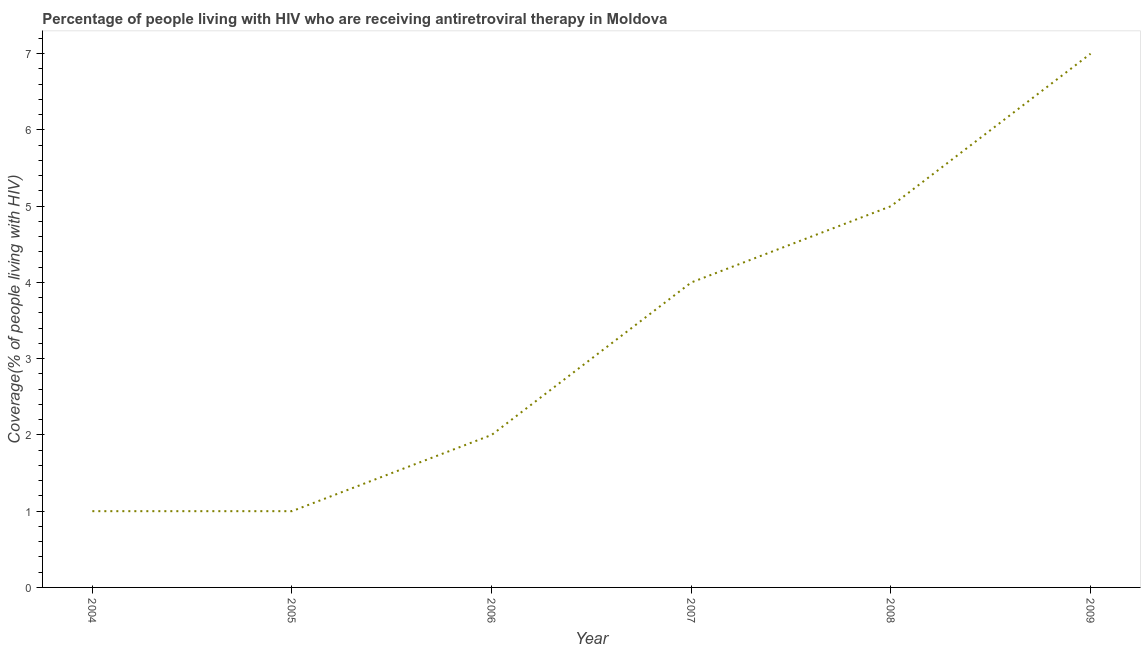What is the antiretroviral therapy coverage in 2004?
Provide a succinct answer. 1. Across all years, what is the maximum antiretroviral therapy coverage?
Offer a very short reply. 7. Across all years, what is the minimum antiretroviral therapy coverage?
Your answer should be compact. 1. In which year was the antiretroviral therapy coverage maximum?
Provide a short and direct response. 2009. In which year was the antiretroviral therapy coverage minimum?
Offer a very short reply. 2004. What is the sum of the antiretroviral therapy coverage?
Provide a short and direct response. 20. What is the difference between the antiretroviral therapy coverage in 2006 and 2007?
Provide a short and direct response. -2. What is the average antiretroviral therapy coverage per year?
Give a very brief answer. 3.33. What is the ratio of the antiretroviral therapy coverage in 2005 to that in 2009?
Provide a short and direct response. 0.14. Is the antiretroviral therapy coverage in 2007 less than that in 2008?
Give a very brief answer. Yes. What is the difference between the highest and the second highest antiretroviral therapy coverage?
Make the answer very short. 2. What is the difference between the highest and the lowest antiretroviral therapy coverage?
Give a very brief answer. 6. Does the antiretroviral therapy coverage monotonically increase over the years?
Ensure brevity in your answer.  No. How many years are there in the graph?
Offer a terse response. 6. What is the difference between two consecutive major ticks on the Y-axis?
Give a very brief answer. 1. Are the values on the major ticks of Y-axis written in scientific E-notation?
Keep it short and to the point. No. Does the graph contain grids?
Give a very brief answer. No. What is the title of the graph?
Provide a short and direct response. Percentage of people living with HIV who are receiving antiretroviral therapy in Moldova. What is the label or title of the Y-axis?
Your response must be concise. Coverage(% of people living with HIV). What is the Coverage(% of people living with HIV) of 2007?
Keep it short and to the point. 4. What is the Coverage(% of people living with HIV) in 2009?
Give a very brief answer. 7. What is the difference between the Coverage(% of people living with HIV) in 2004 and 2005?
Offer a very short reply. 0. What is the difference between the Coverage(% of people living with HIV) in 2004 and 2007?
Make the answer very short. -3. What is the difference between the Coverage(% of people living with HIV) in 2005 and 2008?
Provide a succinct answer. -4. What is the difference between the Coverage(% of people living with HIV) in 2005 and 2009?
Offer a terse response. -6. What is the difference between the Coverage(% of people living with HIV) in 2007 and 2008?
Provide a short and direct response. -1. What is the difference between the Coverage(% of people living with HIV) in 2008 and 2009?
Offer a terse response. -2. What is the ratio of the Coverage(% of people living with HIV) in 2004 to that in 2008?
Ensure brevity in your answer.  0.2. What is the ratio of the Coverage(% of people living with HIV) in 2004 to that in 2009?
Your answer should be compact. 0.14. What is the ratio of the Coverage(% of people living with HIV) in 2005 to that in 2006?
Give a very brief answer. 0.5. What is the ratio of the Coverage(% of people living with HIV) in 2005 to that in 2007?
Your response must be concise. 0.25. What is the ratio of the Coverage(% of people living with HIV) in 2005 to that in 2008?
Keep it short and to the point. 0.2. What is the ratio of the Coverage(% of people living with HIV) in 2005 to that in 2009?
Provide a short and direct response. 0.14. What is the ratio of the Coverage(% of people living with HIV) in 2006 to that in 2007?
Provide a succinct answer. 0.5. What is the ratio of the Coverage(% of people living with HIV) in 2006 to that in 2008?
Your answer should be compact. 0.4. What is the ratio of the Coverage(% of people living with HIV) in 2006 to that in 2009?
Offer a very short reply. 0.29. What is the ratio of the Coverage(% of people living with HIV) in 2007 to that in 2008?
Provide a succinct answer. 0.8. What is the ratio of the Coverage(% of people living with HIV) in 2007 to that in 2009?
Your answer should be compact. 0.57. What is the ratio of the Coverage(% of people living with HIV) in 2008 to that in 2009?
Make the answer very short. 0.71. 